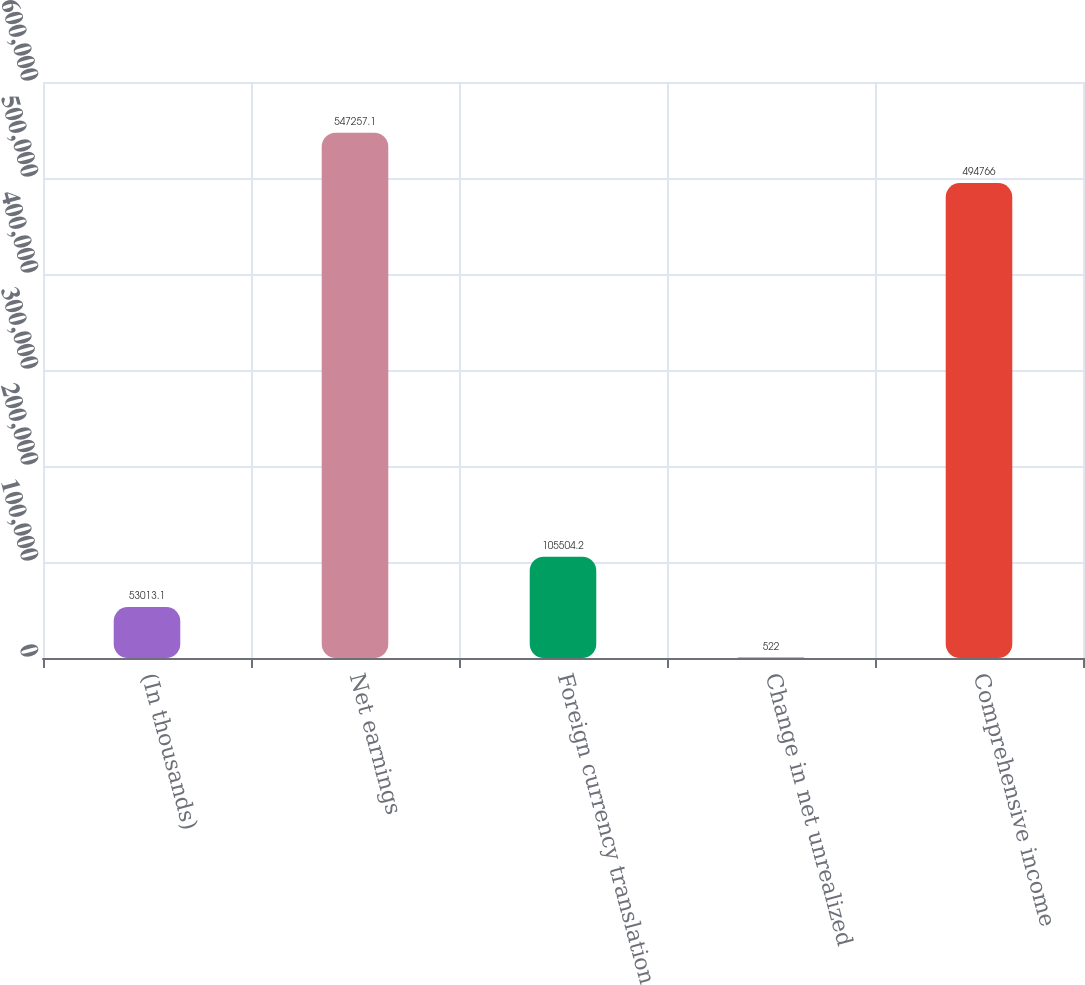Convert chart to OTSL. <chart><loc_0><loc_0><loc_500><loc_500><bar_chart><fcel>(In thousands)<fcel>Net earnings<fcel>Foreign currency translation<fcel>Change in net unrealized<fcel>Comprehensive income<nl><fcel>53013.1<fcel>547257<fcel>105504<fcel>522<fcel>494766<nl></chart> 